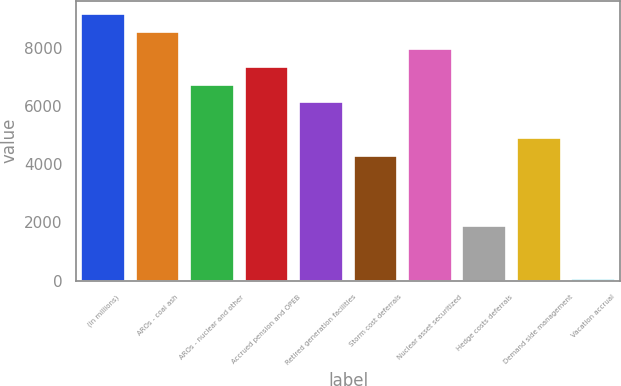Convert chart. <chart><loc_0><loc_0><loc_500><loc_500><bar_chart><fcel>(in millions)<fcel>AROs - coal ash<fcel>AROs - nuclear and other<fcel>Accrued pension and OPEB<fcel>Retired generation facilities<fcel>Storm cost deferrals<fcel>Nuclear asset securitized<fcel>Hedge costs deferrals<fcel>Demand side management<fcel>Vacation accrual<nl><fcel>9165.5<fcel>8557<fcel>6731.5<fcel>7340<fcel>6123<fcel>4297.5<fcel>7948.5<fcel>1863.5<fcel>4906<fcel>38<nl></chart> 